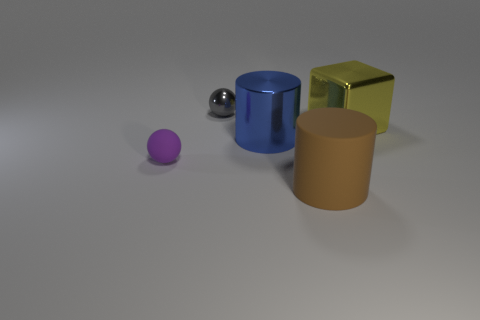Add 2 big cyan metallic objects. How many objects exist? 7 Subtract all cubes. How many objects are left? 4 Subtract all large green matte things. Subtract all brown matte things. How many objects are left? 4 Add 2 blue objects. How many blue objects are left? 3 Add 1 large brown rubber objects. How many large brown rubber objects exist? 2 Subtract 1 yellow blocks. How many objects are left? 4 